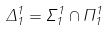Convert formula to latex. <formula><loc_0><loc_0><loc_500><loc_500>\Delta _ { 1 } ^ { 1 } = \Sigma _ { 1 } ^ { 1 } \cap \Pi _ { 1 } ^ { 1 }</formula> 